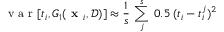<formula> <loc_0><loc_0><loc_500><loc_500>v a r [ t _ { i } , G _ { 1 } ( x _ { i } , \mathcal { D } ) ] \approx \frac { 1 } { s } \, \sum _ { j } ^ { s } \, 0 . 5 \, ( t _ { i } - t _ { i } ^ { j } ) ^ { 2 }</formula> 